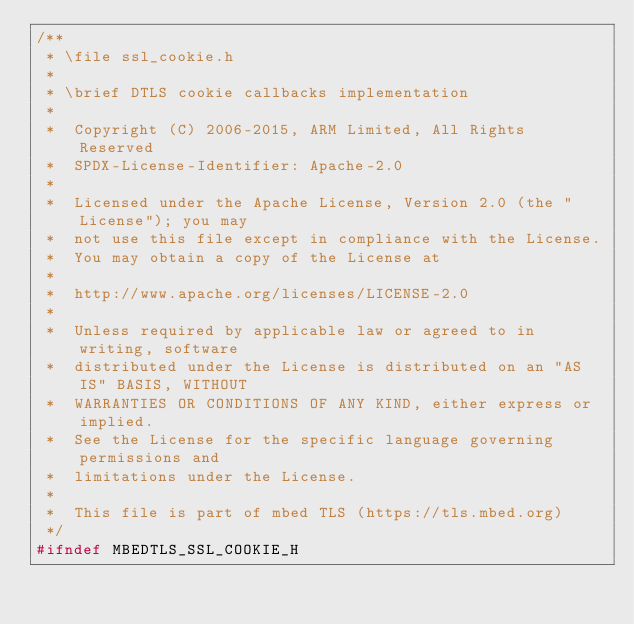<code> <loc_0><loc_0><loc_500><loc_500><_C_>/**
 * \file ssl_cookie.h
 *
 * \brief DTLS cookie callbacks implementation
 *
 *  Copyright (C) 2006-2015, ARM Limited, All Rights Reserved
 *  SPDX-License-Identifier: Apache-2.0
 *
 *  Licensed under the Apache License, Version 2.0 (the "License"); you may
 *  not use this file except in compliance with the License.
 *  You may obtain a copy of the License at
 *
 *  http://www.apache.org/licenses/LICENSE-2.0
 *
 *  Unless required by applicable law or agreed to in writing, software
 *  distributed under the License is distributed on an "AS IS" BASIS, WITHOUT
 *  WARRANTIES OR CONDITIONS OF ANY KIND, either express or implied.
 *  See the License for the specific language governing permissions and
 *  limitations under the License.
 *
 *  This file is part of mbed TLS (https://tls.mbed.org)
 */
#ifndef MBEDTLS_SSL_COOKIE_H</code> 